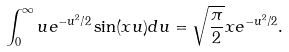<formula> <loc_0><loc_0><loc_500><loc_500>\int _ { 0 } ^ { \infty } u e ^ { - u ^ { 2 } / 2 } \sin ( x u ) d u = \sqrt { \frac { \pi } { 2 } } x e ^ { - u ^ { 2 } / 2 } .</formula> 